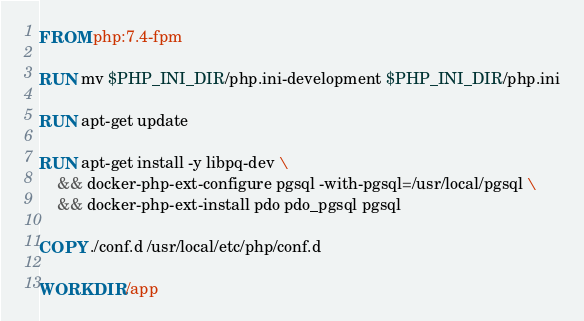Convert code to text. <code><loc_0><loc_0><loc_500><loc_500><_Dockerfile_>FROM php:7.4-fpm

RUN mv $PHP_INI_DIR/php.ini-development $PHP_INI_DIR/php.ini

RUN apt-get update

RUN apt-get install -y libpq-dev \
    && docker-php-ext-configure pgsql -with-pgsql=/usr/local/pgsql \
    && docker-php-ext-install pdo pdo_pgsql pgsql

COPY ./conf.d /usr/local/etc/php/conf.d

WORKDIR /app</code> 